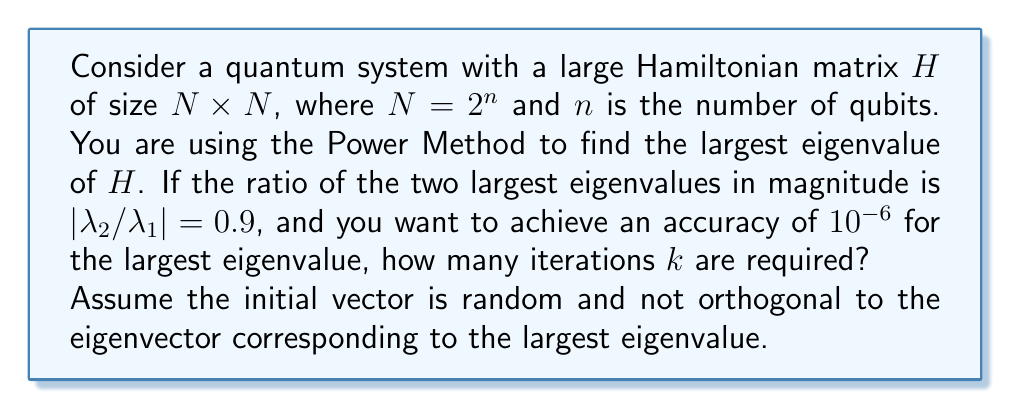Teach me how to tackle this problem. Let's approach this step-by-step:

1) The Power Method converges to the largest eigenvalue $\lambda_1$ with a rate determined by the ratio $|\lambda_2 / \lambda_1|$, where $\lambda_2$ is the second largest eigenvalue in magnitude.

2) The error after $k$ iterations is proportional to $|\lambda_2 / \lambda_1|^k$. Specifically:

   $$ \text{Error} \approx C \left|\frac{\lambda_2}{\lambda_1}\right|^k $$

   where $C$ is a constant depending on the initial vector.

3) We want this error to be less than $10^{-6}$. So we need to solve:

   $$ C (0.9)^k \leq 10^{-6} $$

4) Taking logarithms of both sides:

   $$ \log C + k \log 0.9 \leq \log 10^{-6} = -6 \log 10 $$

5) We don't know $C$, but we can assume it's not too large, say $C \approx 1$. This gives us a conservative estimate:

   $$ k \log 0.9 \leq -6 \log 10 $$

6) Solving for $k$:

   $$ k \geq \frac{-6 \log 10}{\log 0.9} \approx 131.45 $$

7) Since $k$ must be an integer, we round up to the next whole number.

Therefore, at least 132 iterations are required to achieve the desired accuracy.
Answer: 132 iterations 